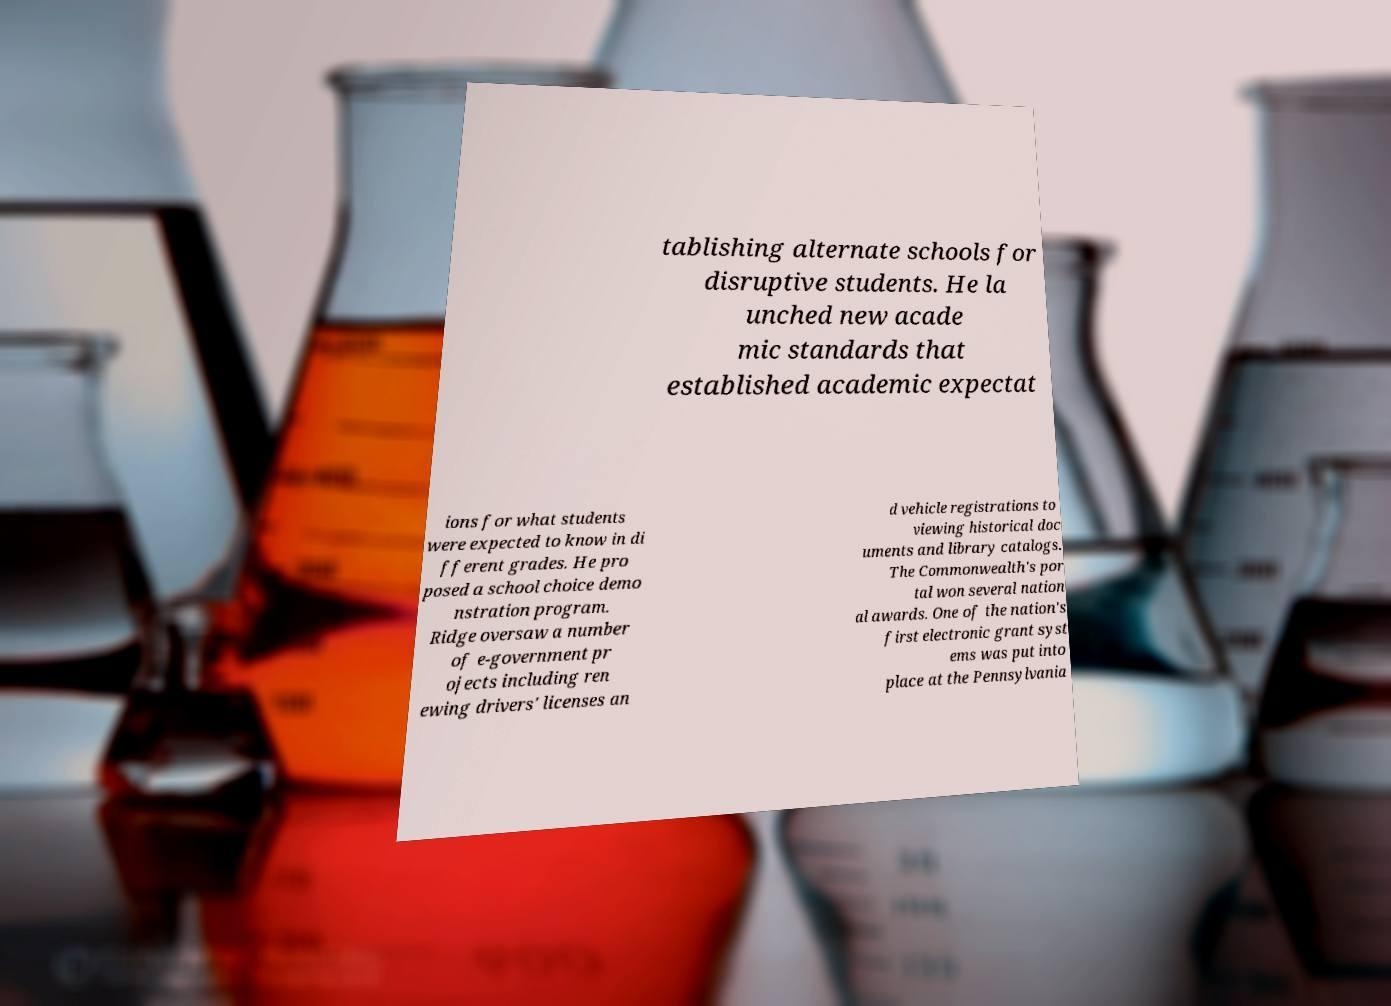For documentation purposes, I need the text within this image transcribed. Could you provide that? tablishing alternate schools for disruptive students. He la unched new acade mic standards that established academic expectat ions for what students were expected to know in di fferent grades. He pro posed a school choice demo nstration program. Ridge oversaw a number of e-government pr ojects including ren ewing drivers' licenses an d vehicle registrations to viewing historical doc uments and library catalogs. The Commonwealth's por tal won several nation al awards. One of the nation's first electronic grant syst ems was put into place at the Pennsylvania 